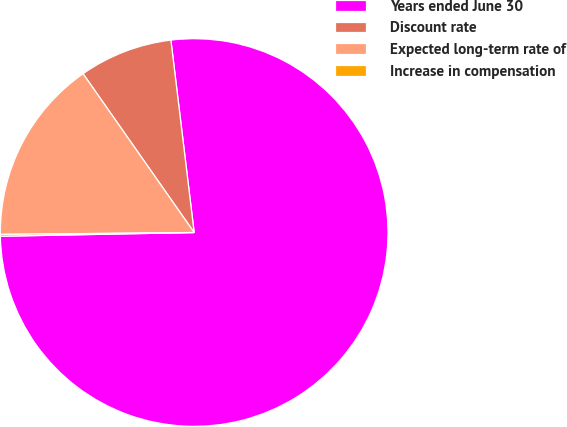Convert chart. <chart><loc_0><loc_0><loc_500><loc_500><pie_chart><fcel>Years ended June 30<fcel>Discount rate<fcel>Expected long-term rate of<fcel>Increase in compensation<nl><fcel>76.61%<fcel>7.8%<fcel>15.44%<fcel>0.15%<nl></chart> 